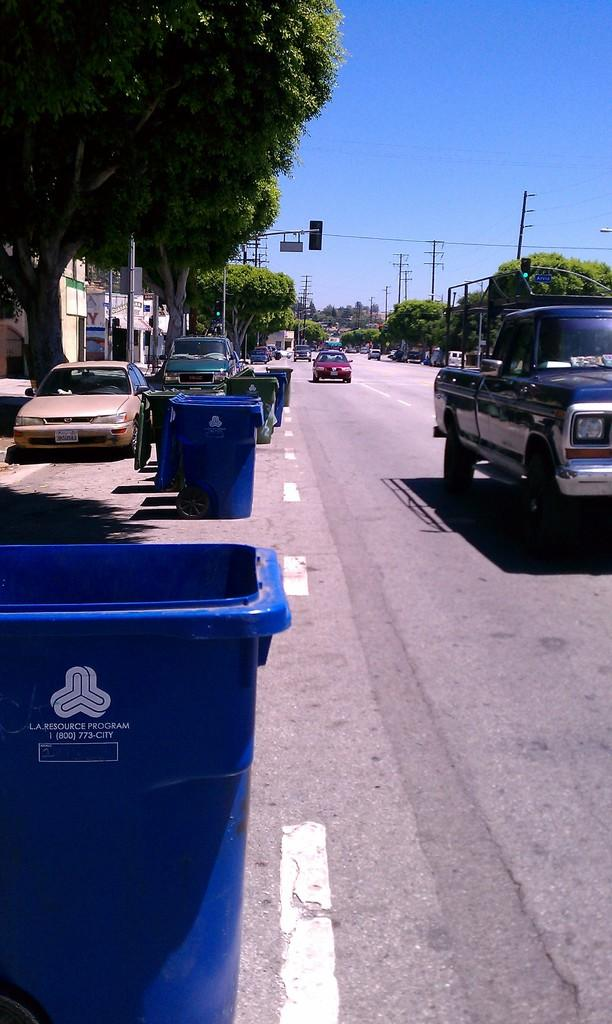What type of vehicles can be seen on the road in the image? There are cars on the road in the image. Are there any other types of vehicles visible besides cars? Yes, there are trucks on the left side of the road in the image. What can be seen on either side of the road in the image? There are trees on either side of the road in the image. What is visible above the road in the image? The sky is visible above the road in the image. Who is the owner of the sidewalk in the image? There is no sidewalk present in the image, so it is not possible to determine the owner. 